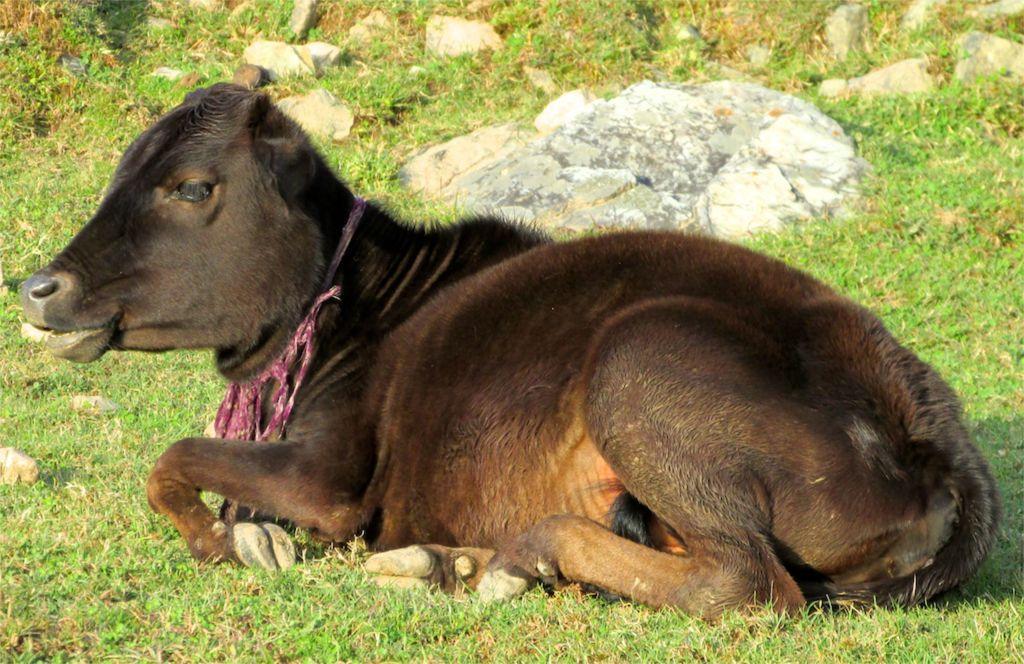Could you give a brief overview of what you see in this image? In this picture we can see an animal on the ground and in the background we can see the grass, some stones. 